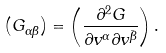<formula> <loc_0><loc_0><loc_500><loc_500>\left ( G _ { \alpha \bar { \beta } } \right ) = \left ( \frac { \partial ^ { 2 } G } { \partial v ^ { \alpha } \partial v ^ { \bar { \beta } } } \right ) .</formula> 